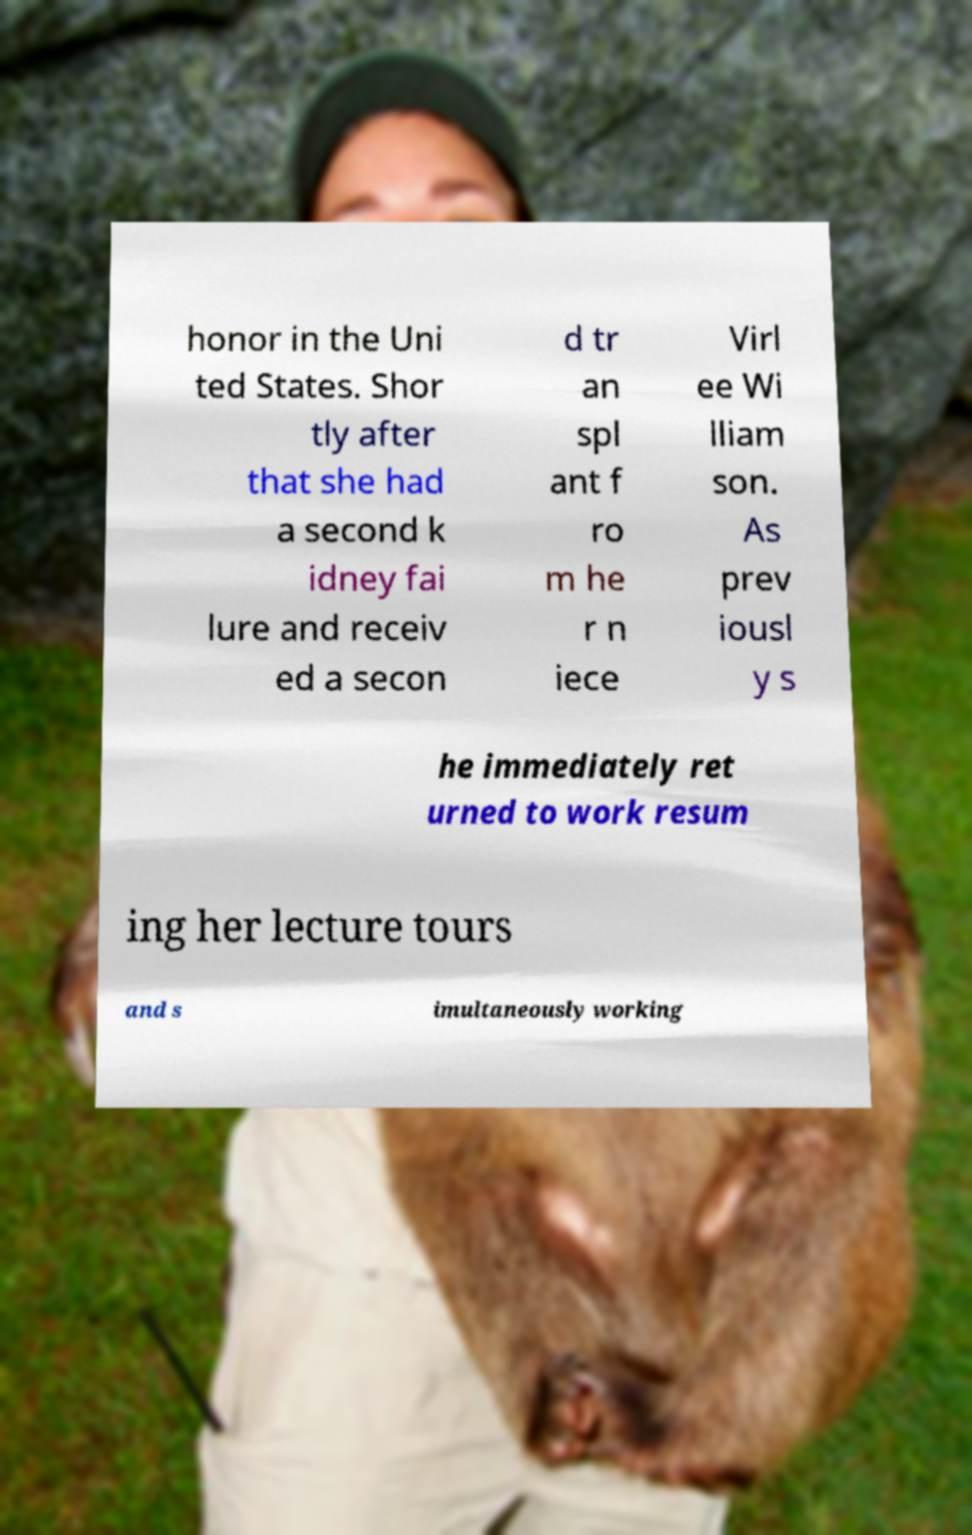There's text embedded in this image that I need extracted. Can you transcribe it verbatim? honor in the Uni ted States. Shor tly after that she had a second k idney fai lure and receiv ed a secon d tr an spl ant f ro m he r n iece Virl ee Wi lliam son. As prev iousl y s he immediately ret urned to work resum ing her lecture tours and s imultaneously working 